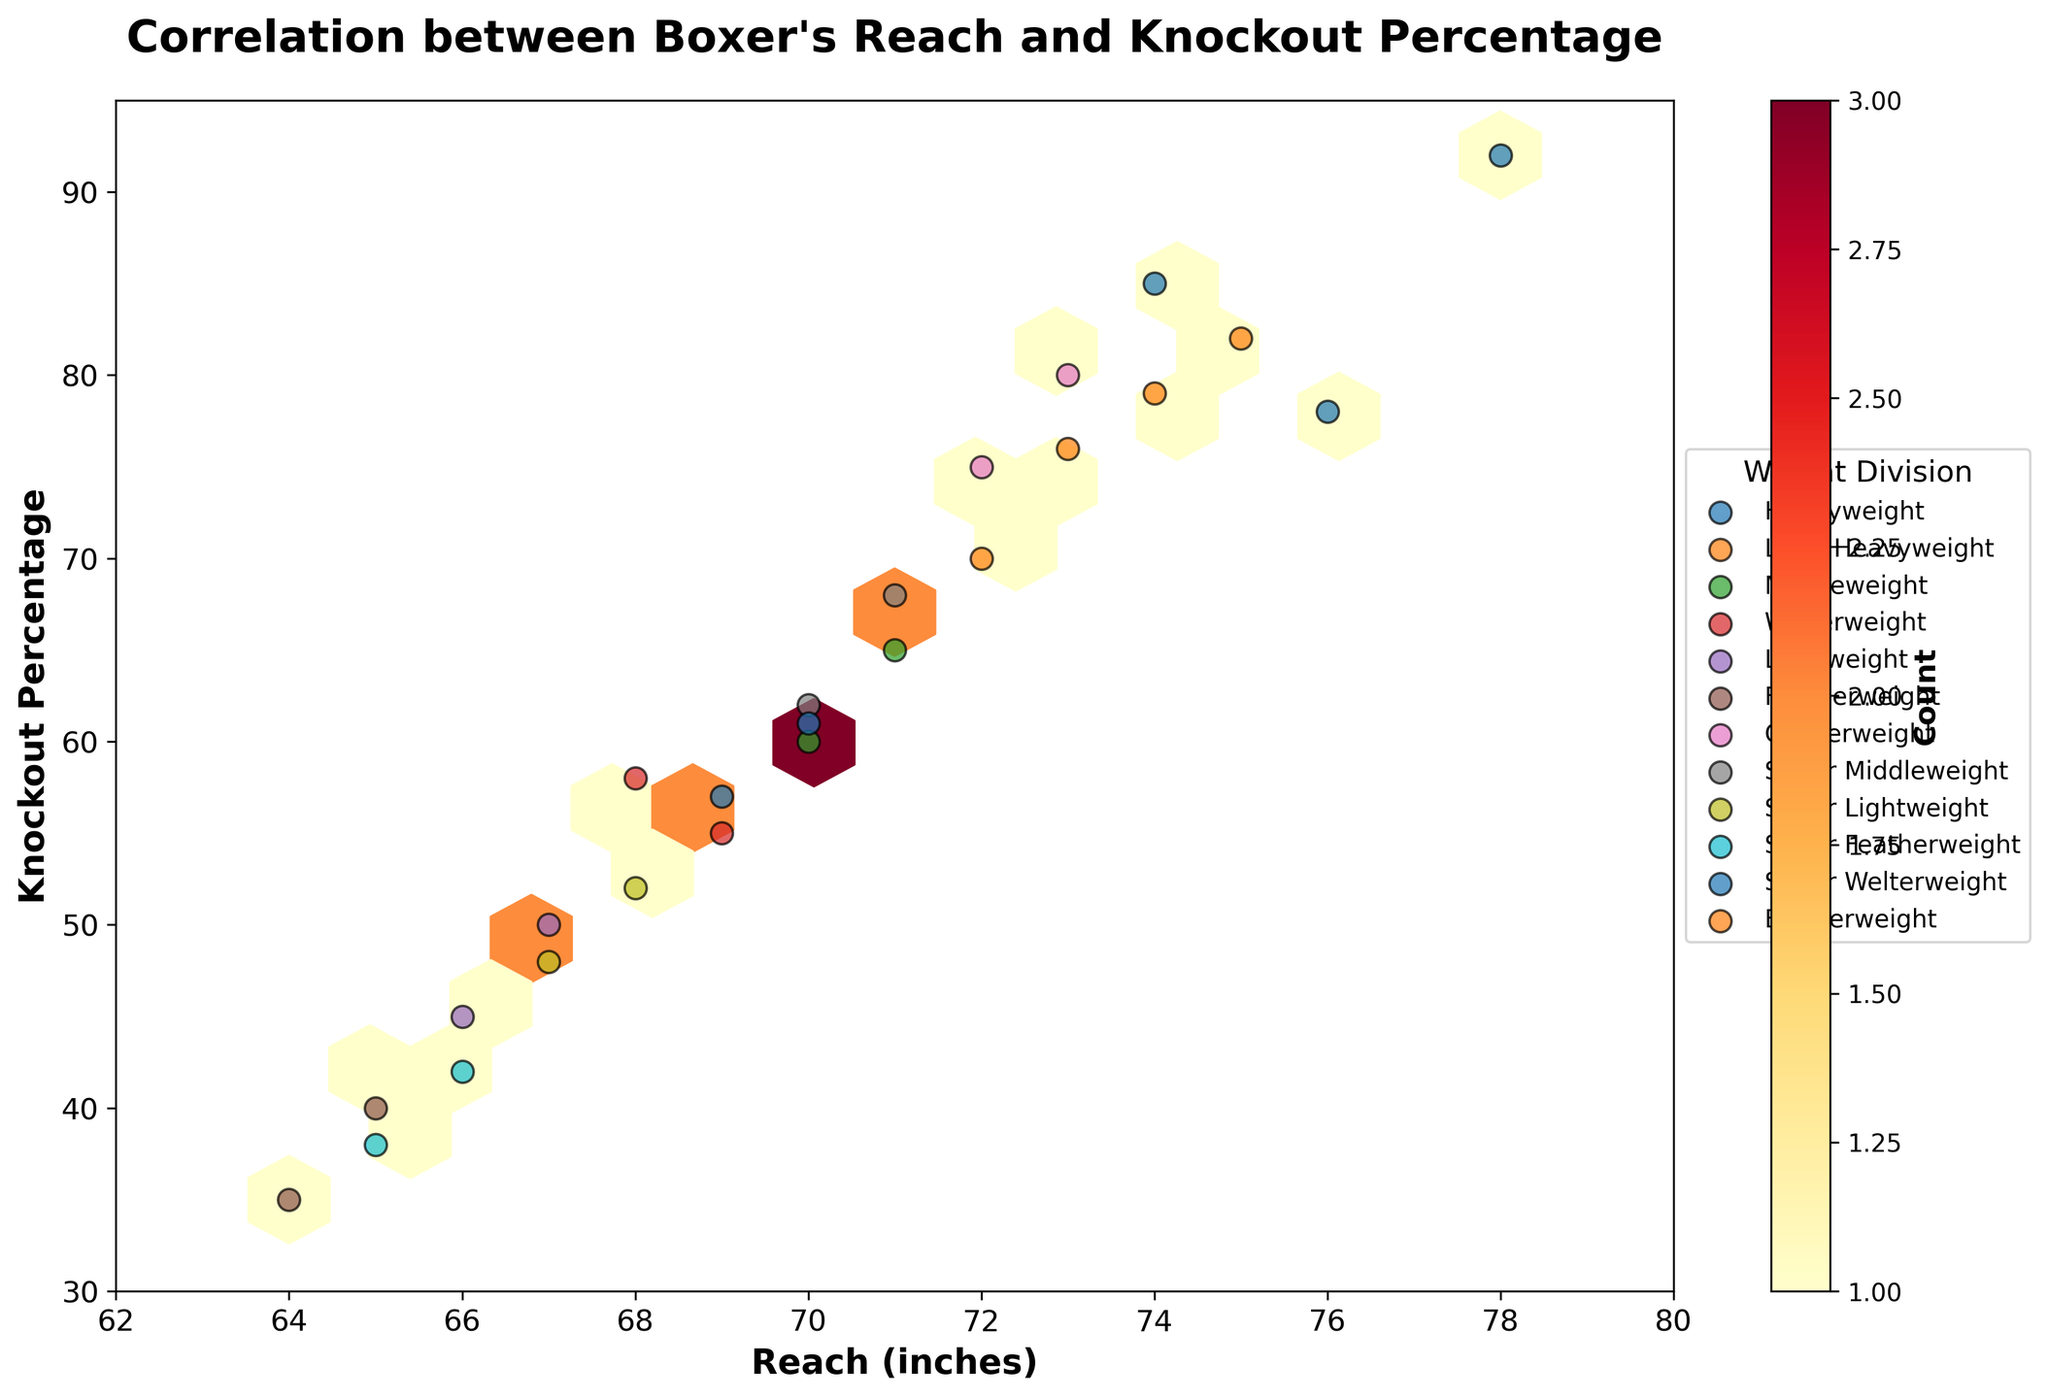What is the color pattern used for the hexagonal bins? The hexagonal bins are colored using a gradient from light yellow to dark red to represent different densities of points. Light yellow indicates lower densities, while dark red indicates higher densities.
Answer: Yellows to Reds What's the title of the figure? The title of the figure is given in bold at the top of the chart. It clearly states the purpose of the visual representation.
Answer: Correlation between Boxer's Reach and Knockout Percentage How are different weight divisions represented in the figure? Each weight division is represented by differently colored scatter points, which are also labeled in the legend on the right of the figure. These points are scattered across the hexbin plot.
Answer: By colors and labels Which weight division has the boxer with the highest knockout percentage? By looking for the scatter point located at the highest knockout percentage along the y-axis and referring to its color and corresponding label in the legend, the boxer with the highest knockout percentage belongs to the Heavyweight division.
Answer: Heavyweight Which reach range shows the most overlap of different weight divisions? Observing where multiple colored scatter points representing different weight divisions cluster closely together within a certain reach range will indicate the area of overlap. The 70-74 inches reach range shows the most overlap of different weight divisions.
Answer: 70-74 inches How many weight divisions are plotted on the hexbin plot? By counting the distinct labels in the legend, we can determine the number of different weight divisions represented in the figure.
Answer: 11 What is the overall correlation observed between reach and knockout percentage? Observing the trend of scatter points and hexagons, the overall trend shows that as reach increases, the knockout percentage generally increases. This is indicative of a positive correlation.
Answer: Positive correlation Which weight division shows the biggest spread in knockout percentage for similar reach ranges? By identifying where multiple points from the same weight division, distinguished by the same color and label, are spread out vertically across different knockout percentages within the same reach range, we can determine that the Light Heavyweight division shows a wide spread in knockout percentage for similar reaches.
Answer: Light Heavyweight What weight division corresponds to a knockout percentage of around 80% and a reach close to 73 inches? Locate the scatter point around 80% knockout percentage and 73 inches reach, then refer to its color and label in the legend to identify the weight division, which is the Cruiserweight division.
Answer: Cruiserweight Do boxers with greater than 78 inches reach have a consistent knockout percentage above 90% in any division? By checking for any scatter points above 90% knockout percentage in the reach range greater than 78 inches, we see such points exist, and they belong to the Heavyweight division.
Answer: Yes, Heavyweight 